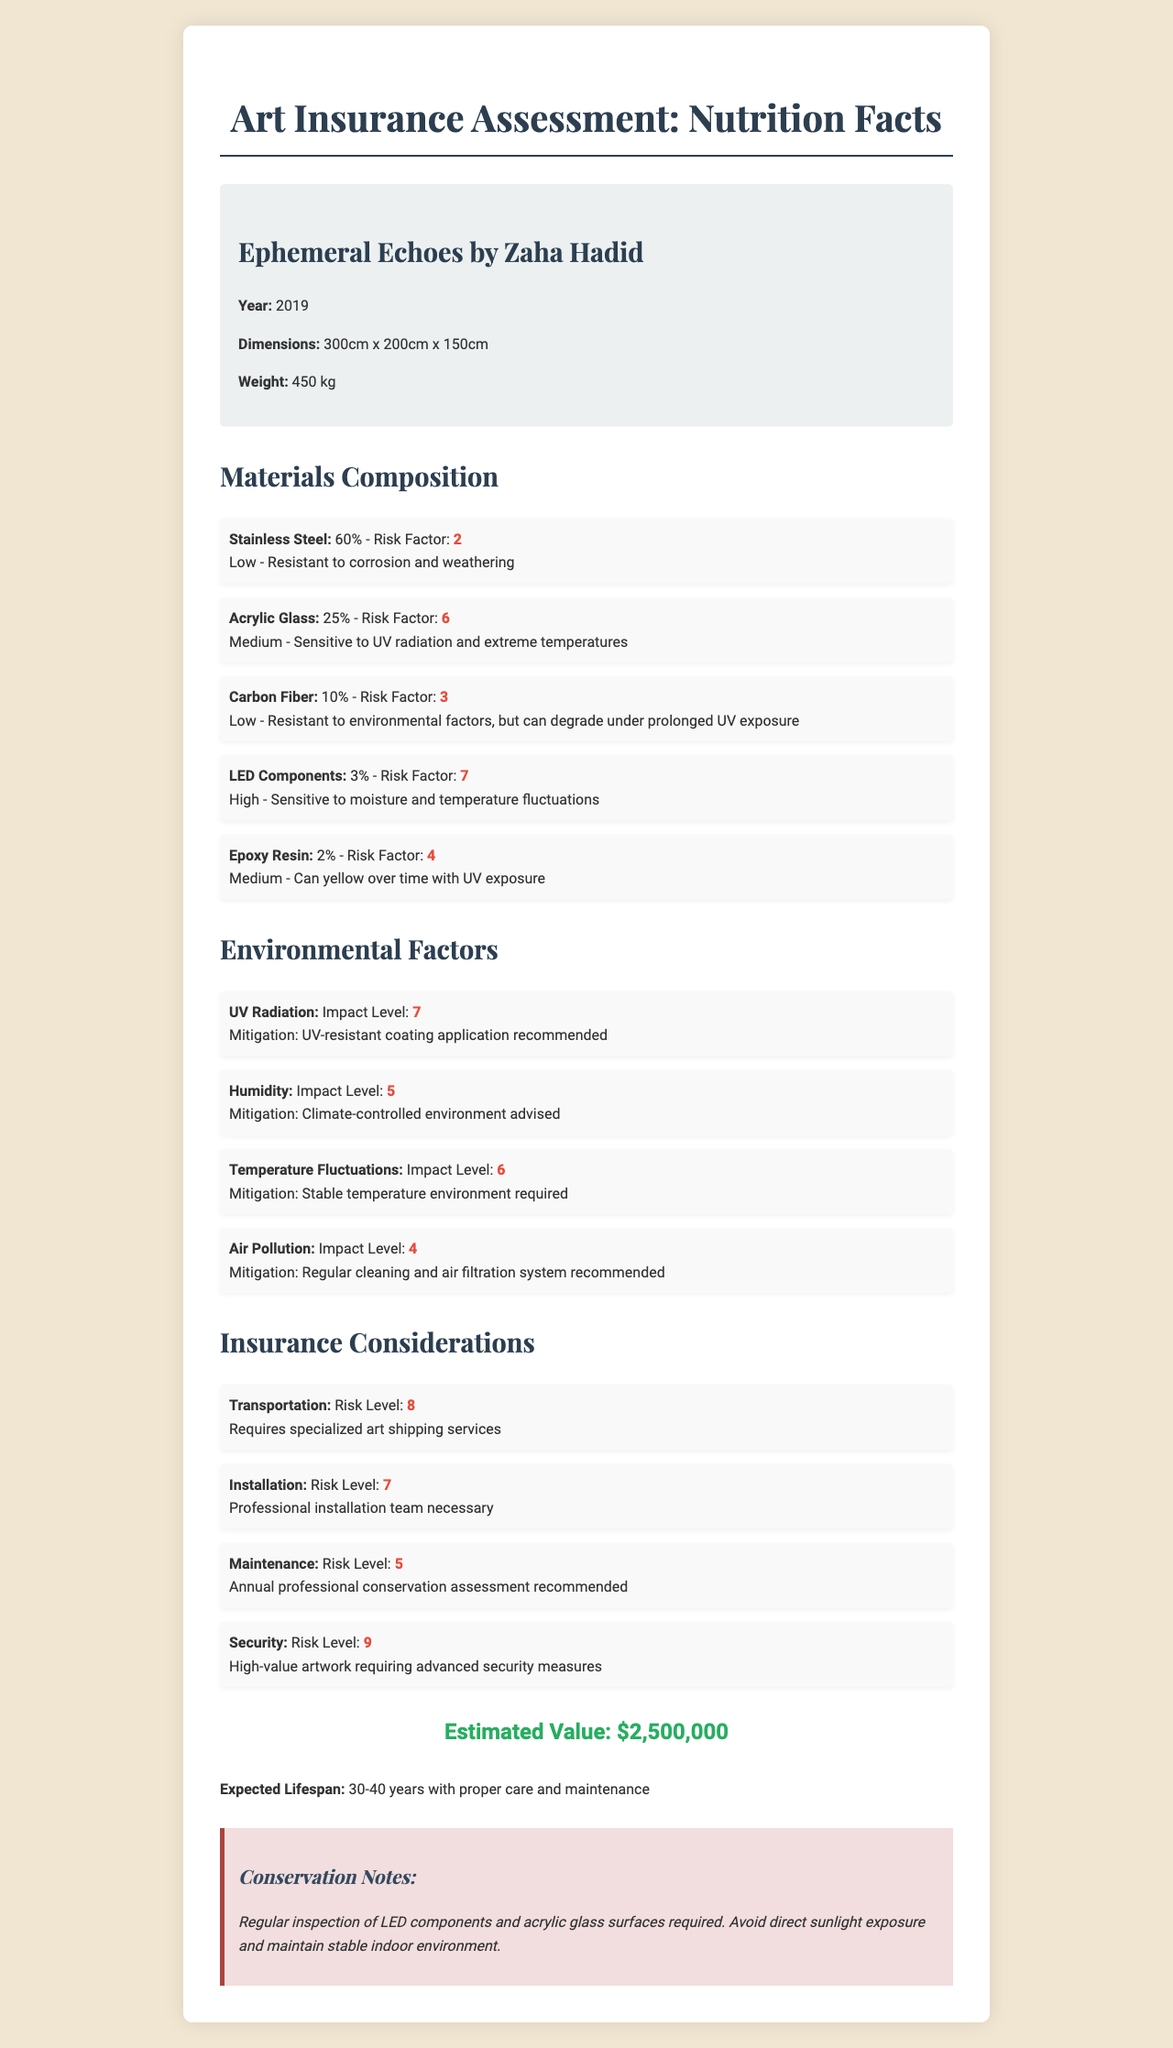what is the artwork's name? The document specifies the artwork name as "Ephemeral Echoes."
Answer: Ephemeral Echoes who is the artist of the artwork? The document lists Zaha Hadid as the artist of the artwork.
Answer: Zaha Hadid what year was the artwork created? The document indicates that the artwork was created in 2019.
Answer: 2019 what are the dimensions of the artwork? The dimensions of the artwork are listed as 300cm x 200cm x 150cm in the document.
Answer: 300cm x 200cm x 150cm what is the estimated value of the artwork? The estimated value of the artwork is stated as $2,500,000.
Answer: $2,500,000 which material has the highest risk factor? A. Stainless Steel B. Acrylic Glass C. Carbon Fiber D. LED Components E. Epoxy Resin The document shows that LED Components have a risk factor of 7, which is the highest among the listed materials.
Answer: D. LED Components which environmental factor has the lowest impact level? 1. UV Radiation 2. Humidity 3. Temperature Fluctuations 4. Air Pollution The document lists Air Pollution with an impact level of 4, which is the lowest among the given factors.
Answer: 4. Air Pollution Is the sculpture susceptible to humidity? The document notes that humidity has an impact level of 5 and advises a climate-controlled environment, indicating susceptibility.
Answer: Yes summarize the main idea of the document. The document comprehensively evaluates the sculpture's composition, potential environmental impacts, maintenance recommendations, and insurance aspects.
Answer: The document provides a detailed assessment of the sculpture "Ephemeral Echoes" by Zaha Hadid, including its dimensions, materials, environmental susceptibilities, insurance considerations, estimated value, lifespan, and conservation notes. It indicates the materials used, their risk factors, and the recommended environmental conditions to mitigate risks. how can the impact of UV radiation be mitigated? The document suggests applying a UV-resistant coating to mitigate the impact of UV radiation.
Answer: UV-resistant coating application recommended what is the weight of the sculpture? The document states that the weight of the sculpture is 450 kg.
Answer: 450 kg which material is least susceptible to environmental factors? The document indicates that Stainless Steel has low susceptibility to environmental factors and is resistant to corrosion and weathering.
Answer: Stainless Steel which factors require a stable indoor environment to avoid damage? The document mentions that UV radiation and temperature fluctuations necessitate a stable indoor environment to prevent damage to the sculpture.
Answer: UV Radiation, Temperature Fluctuations what are the primary conservation actions recommended for the artwork? The document outlines these actions as essential for the conservation of the artwork.
Answer: Regular inspection of LED components and acrylic glass surfaces, avoid direct sunlight exposure, maintain stable indoor environment what is the expected lifespan of the artwork with proper care and maintenance? The document states the expected lifespan as 30-40 years with proper care and maintenance.
Answer: 30-40 years what do you need to consider when transporting the sculpture? The document highlights that transportation of the sculpture has a high-risk level of 8 and requires specialized art shipping services.
Answer: Requires specialized art shipping services which material is most sensitive to UV radiation and extreme temperatures? The document notes that Acrylic Glass has medium sensitivity to UV radiation and extreme temperatures.
Answer: Acrylic Glass what is the risk level for the maintenance of the sculpture? The document lists maintenance with a risk level of 5.
Answer: 5 what kind of installation team is necessary for the sculpture? The document notes that professional installation is required due to the high-risk level of 7 for installation.
Answer: Professional installation team necessary does the document explain how to clean the artwork? The document does not provide specific details on the cleaning process for the artwork, only a general recommendation for regular inspection and maintenance.
Answer: Not enough information 